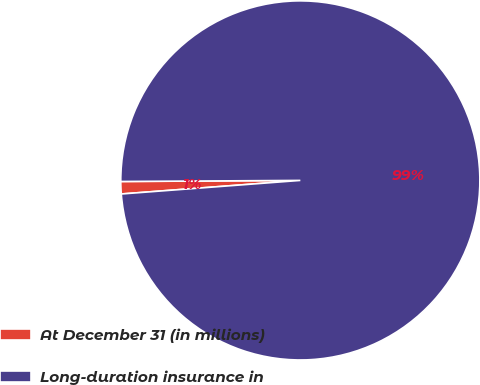Convert chart. <chart><loc_0><loc_0><loc_500><loc_500><pie_chart><fcel>At December 31 (in millions)<fcel>Long-duration insurance in<nl><fcel>1.11%<fcel>98.89%<nl></chart> 